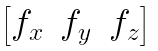Convert formula to latex. <formula><loc_0><loc_0><loc_500><loc_500>\begin{bmatrix} f _ { x } & f _ { y } & f _ { z } \end{bmatrix}</formula> 